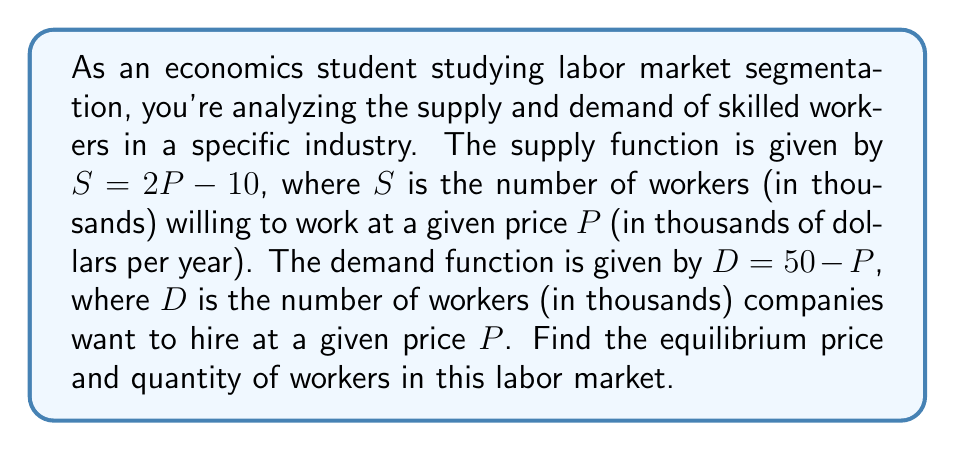What is the answer to this math problem? To find the equilibrium point, we need to solve for where supply equals demand:

1) Set the supply and demand equations equal to each other:
   $S = D$
   $2P - 10 = 50 - P$

2) Solve for $P$:
   $2P - 10 = 50 - P$
   $2P + P = 50 + 10$
   $3P = 60$
   $P = 20$

3) Now that we know the equilibrium price, we can substitute this back into either the supply or demand equation to find the equilibrium quantity. Let's use the supply equation:

   $S = 2P - 10$
   $S = 2(20) - 10$
   $S = 40 - 10$
   $S = 30$

Therefore, the equilibrium price is $20,000 per year, and the equilibrium quantity is 30,000 workers.
Answer: Equilibrium price: $P = 20$ (thousand dollars per year)
Equilibrium quantity: $S = D = 30$ (thousand workers) 